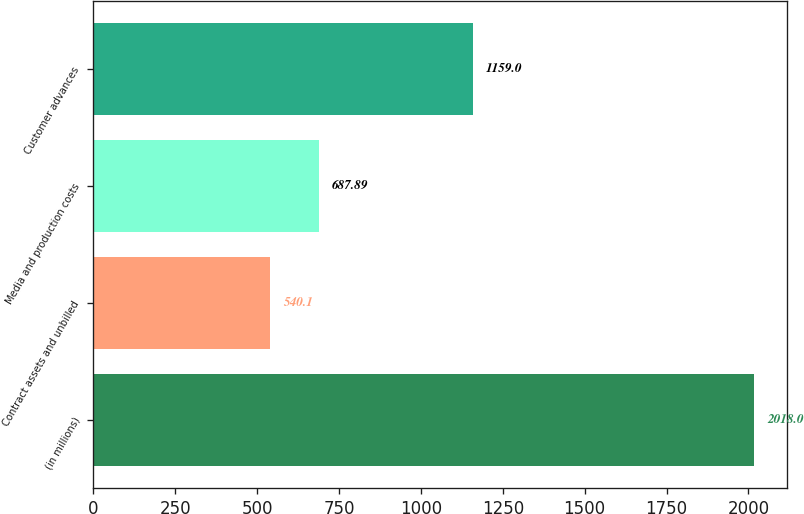Convert chart. <chart><loc_0><loc_0><loc_500><loc_500><bar_chart><fcel>(in millions)<fcel>Contract assets and unbilled<fcel>Media and production costs<fcel>Customer advances<nl><fcel>2018<fcel>540.1<fcel>687.89<fcel>1159<nl></chart> 